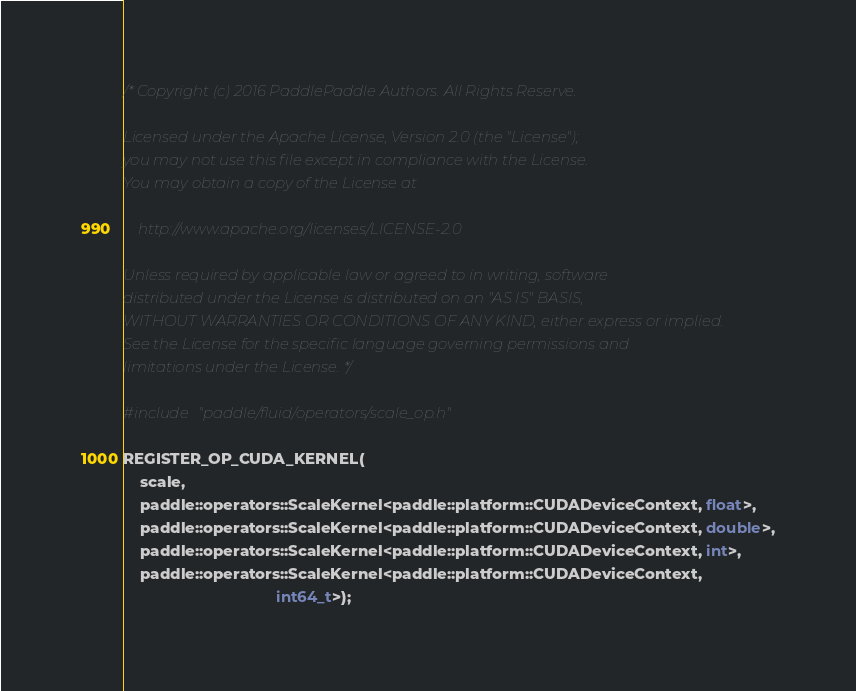<code> <loc_0><loc_0><loc_500><loc_500><_Cuda_>/* Copyright (c) 2016 PaddlePaddle Authors. All Rights Reserve.

Licensed under the Apache License, Version 2.0 (the "License");
you may not use this file except in compliance with the License.
You may obtain a copy of the License at

    http://www.apache.org/licenses/LICENSE-2.0

Unless required by applicable law or agreed to in writing, software
distributed under the License is distributed on an "AS IS" BASIS,
WITHOUT WARRANTIES OR CONDITIONS OF ANY KIND, either express or implied.
See the License for the specific language governing permissions and
limitations under the License. */

#include "paddle/fluid/operators/scale_op.h"

REGISTER_OP_CUDA_KERNEL(
    scale,
    paddle::operators::ScaleKernel<paddle::platform::CUDADeviceContext, float>,
    paddle::operators::ScaleKernel<paddle::platform::CUDADeviceContext, double>,
    paddle::operators::ScaleKernel<paddle::platform::CUDADeviceContext, int>,
    paddle::operators::ScaleKernel<paddle::platform::CUDADeviceContext,
                                   int64_t>);
</code> 